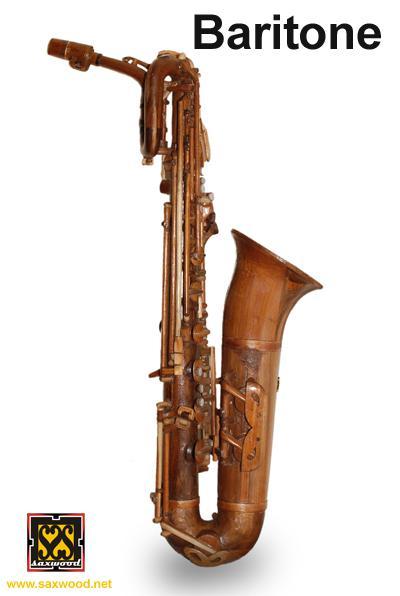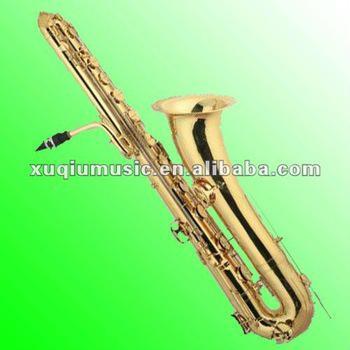The first image is the image on the left, the second image is the image on the right. Assess this claim about the two images: "There are at least four instruments in total shown.". Correct or not? Answer yes or no. No. The first image is the image on the left, the second image is the image on the right. For the images displayed, is the sentence "One image contains three or more saxophones." factually correct? Answer yes or no. No. 